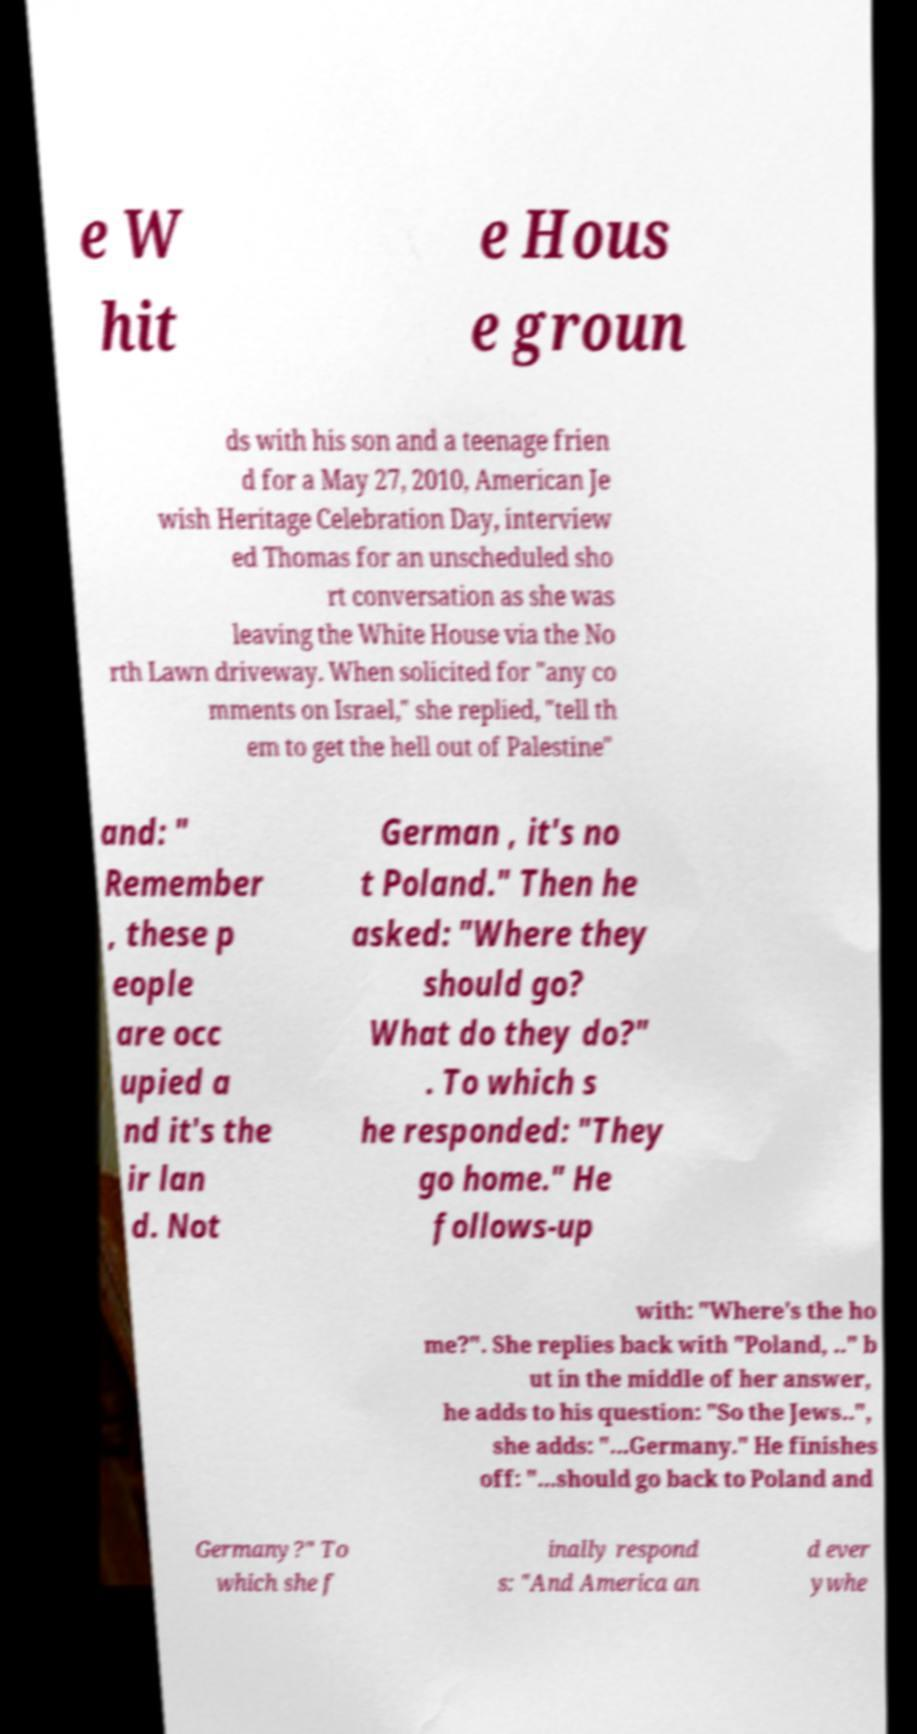Can you accurately transcribe the text from the provided image for me? e W hit e Hous e groun ds with his son and a teenage frien d for a May 27, 2010, American Je wish Heritage Celebration Day, interview ed Thomas for an unscheduled sho rt conversation as she was leaving the White House via the No rth Lawn driveway. When solicited for "any co mments on Israel," she replied, "tell th em to get the hell out of Palestine" and: " Remember , these p eople are occ upied a nd it's the ir lan d. Not German , it's no t Poland." Then he asked: "Where they should go? What do they do?" . To which s he responded: "They go home." He follows-up with: "Where's the ho me?". She replies back with "Poland, .." b ut in the middle of her answer, he adds to his question: "So the Jews..", she adds: "...Germany." He finishes off: "...should go back to Poland and Germany?" To which she f inally respond s: "And America an d ever ywhe 